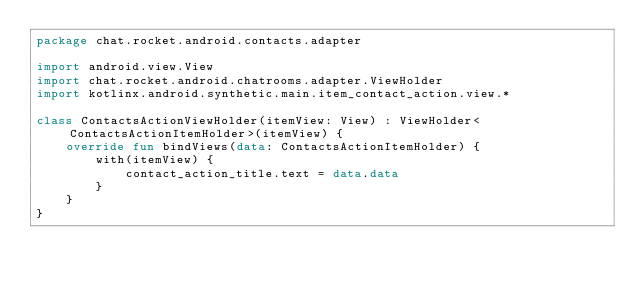<code> <loc_0><loc_0><loc_500><loc_500><_Kotlin_>package chat.rocket.android.contacts.adapter

import android.view.View
import chat.rocket.android.chatrooms.adapter.ViewHolder
import kotlinx.android.synthetic.main.item_contact_action.view.*

class ContactsActionViewHolder(itemView: View) : ViewHolder<ContactsActionItemHolder>(itemView) {
    override fun bindViews(data: ContactsActionItemHolder) {
        with(itemView) {
            contact_action_title.text = data.data
        }
    }
}</code> 